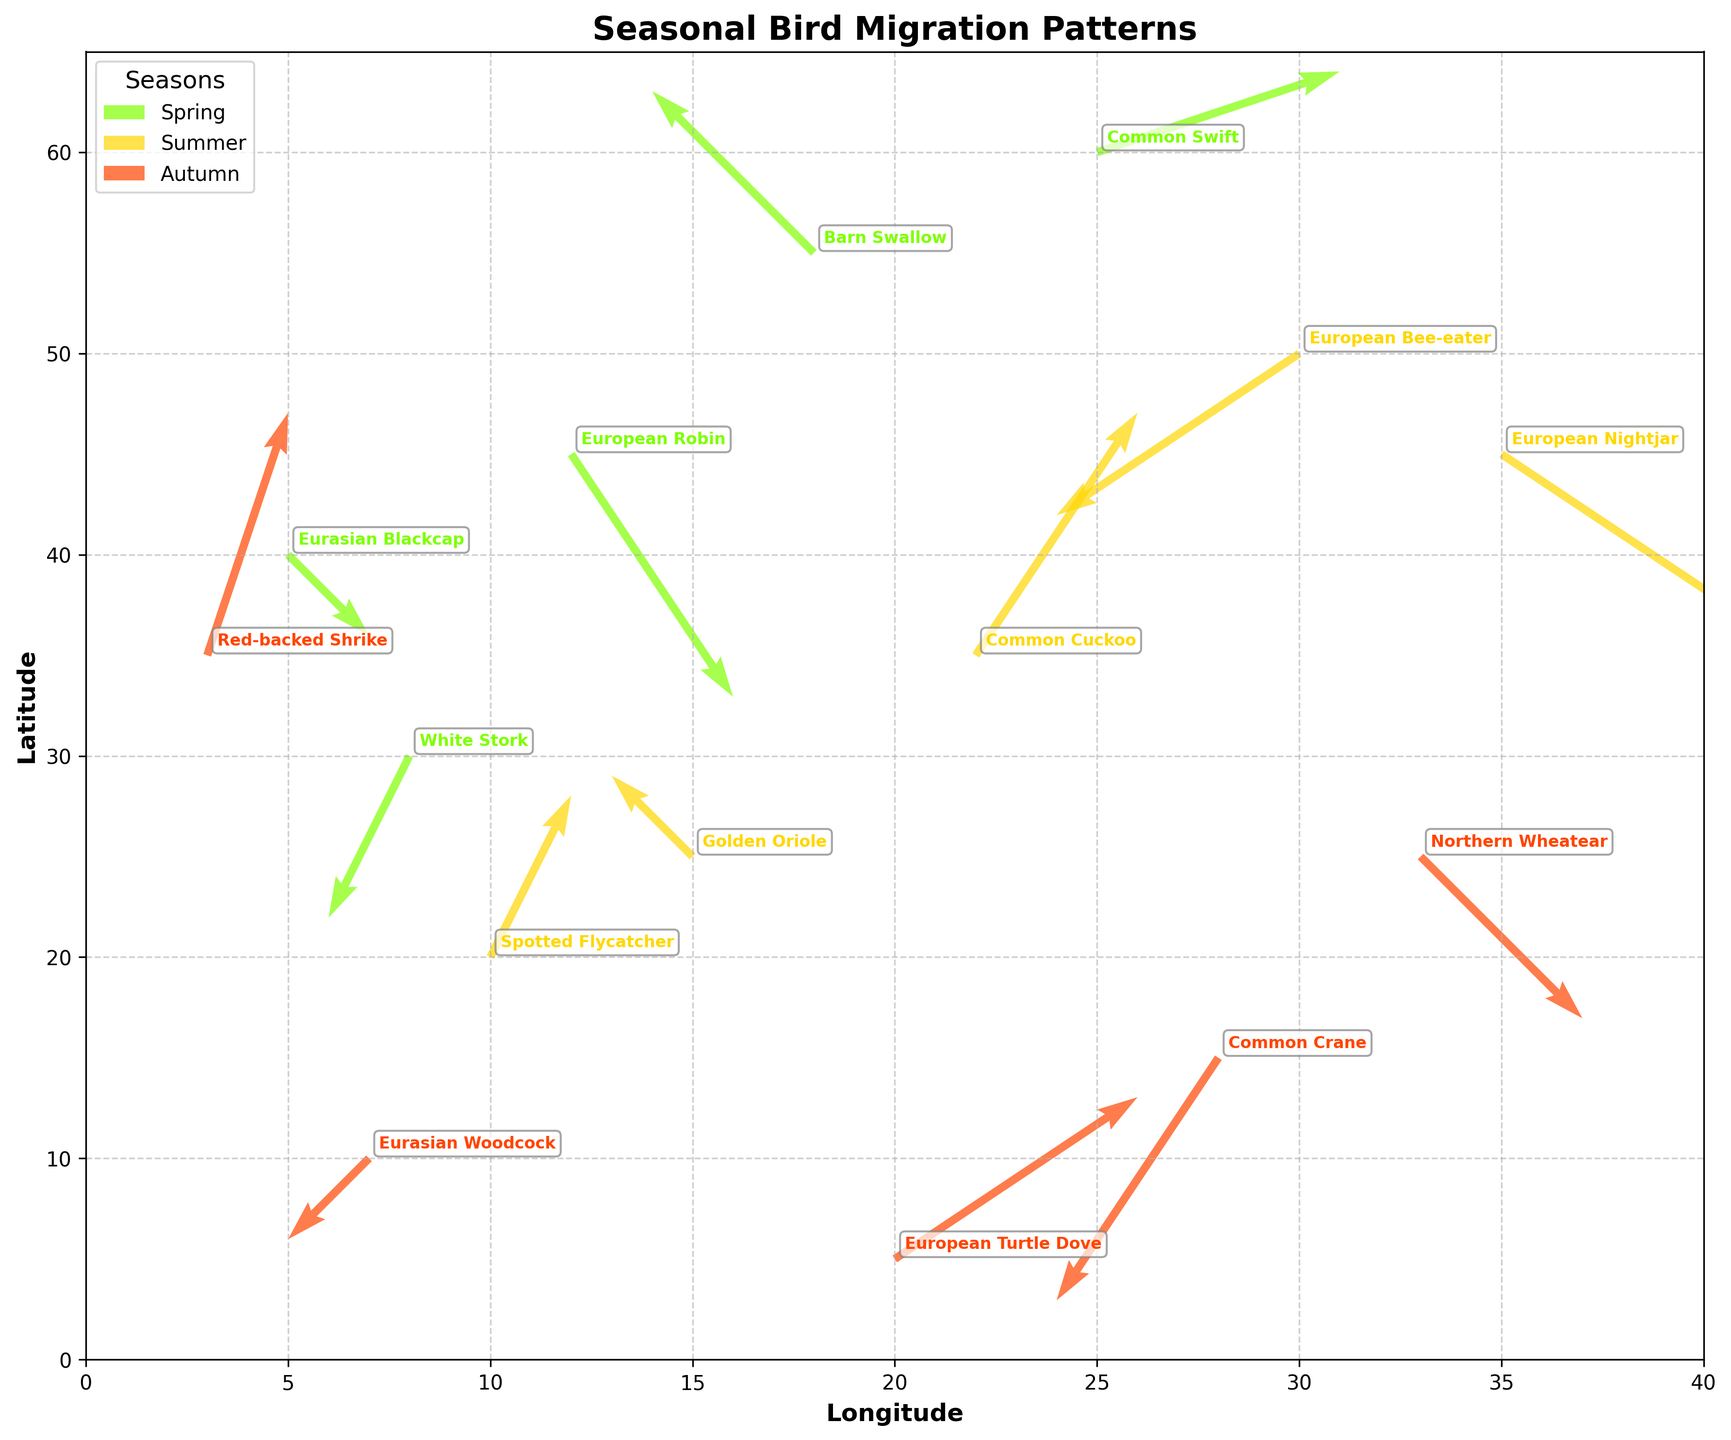How many species are tracked in the plot? The figure has annotations for each bird species. To find the total number, count the individual species labels on the plot.
Answer: 15 Which season has the most bird species depicted in the figure? There are three seasonal legends with different colors: Spring, Summer, and Autumn. Count the number of species for each season to determine the largest group. Spring: 5, Summer: 5, Autumn: 5. All have equal numbers.
Answer: All seasons have 5 species each In which season does the Common Swift migrate, and where does it start from? Locate the annotation "Common Swift" and check its position and arrow direction, then cross-reference its color with the legend to determine the season. The Common Swift is marked in green indicating Spring and starts from (x=25, y=60).
Answer: Spring, (25, 60) Which direction do birds tend to fly during Summer? Look at the arrows corresponding to the Summer color (yellow) and observe their general direction. Most arrows point in various directions including both upward and downward trends, hence there is no specific unified direction.
Answer: Various directions Which bird species moves the furthest during Autumn? Identify which arrow is the longest among the ones colored red (Autumn). Calculate the magnitude by looking at the arrow lengths in terms of both u (horizontal) and v (vertical) components using the Pythagorean theorem. The European Turtle Dove moves the furthest (3, 2).
Answer: European Turtle Dove Do any birds fly the same distance but in different directions? Compare the magnitude of vectors (hypotenuse from u and v values) to see if any birds cover the same distance but have different directions. Both the Barn Swallow (Spring, -2, 2) and the Red-backed Shrike (Autumn, 1, 3) cover the same distance.
Answer: Yes, Barn Swallow and Red-backed Shrike Between the White Stork and the Eurasian Woodcock, which bird flies southward more? Check the direction specifics of the vectors (v component). The White Stork (Spring, 8, 30, u: -1, v: -2) and Eurasian Woodcock (Autumn, 7, 10, u: -1, v: -1), The White Stork's v component is -2, which is more southward than the Eurasian Woodcock’s -1.
Answer: White Stork Which season shows the most concentrated migration activity spatially? Observe the groupings of arrows for each season color and determine which season has arrows most closely clustered together. The Summer (yellow) arrows seem the most spatially concentrated.
Answer: Summer 